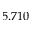Convert formula to latex. <formula><loc_0><loc_0><loc_500><loc_500>5 . 7 1 0</formula> 